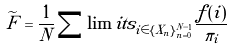Convert formula to latex. <formula><loc_0><loc_0><loc_500><loc_500>\widetilde { F } = \frac { 1 } { N } \sum \lim i t s _ { i \in \{ X _ { n } \} _ { n = 0 } ^ { N - 1 } } \frac { f ( i ) } { \pi _ { i } }</formula> 